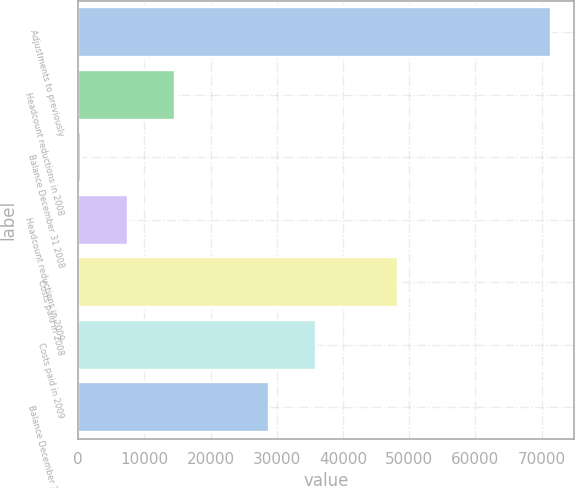Convert chart. <chart><loc_0><loc_0><loc_500><loc_500><bar_chart><fcel>Adjustments to previously<fcel>Headcount reductions in 2008<fcel>Balance December 31 2008<fcel>Headcount reductions in 2009<fcel>Costs paid in 2008<fcel>Costs paid in 2009<fcel>Balance December 31 2009<nl><fcel>71345<fcel>14561<fcel>365<fcel>7463<fcel>48338<fcel>35855<fcel>28757<nl></chart> 